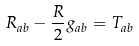Convert formula to latex. <formula><loc_0><loc_0><loc_500><loc_500>R _ { a b } - \frac { R } { 2 } g _ { a b } = T _ { a b }</formula> 